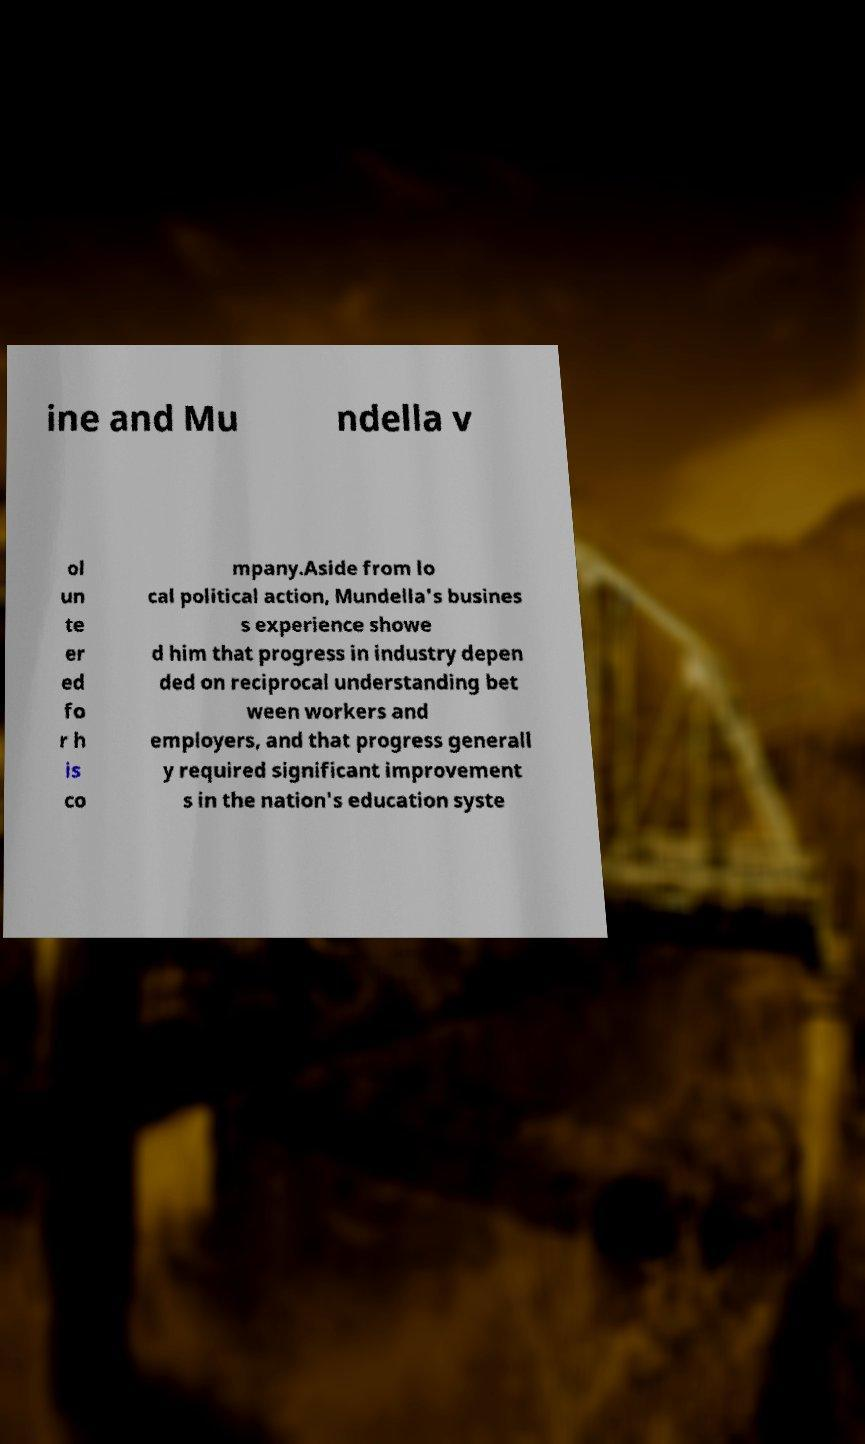Can you read and provide the text displayed in the image?This photo seems to have some interesting text. Can you extract and type it out for me? ine and Mu ndella v ol un te er ed fo r h is co mpany.Aside from lo cal political action, Mundella's busines s experience showe d him that progress in industry depen ded on reciprocal understanding bet ween workers and employers, and that progress generall y required significant improvement s in the nation's education syste 